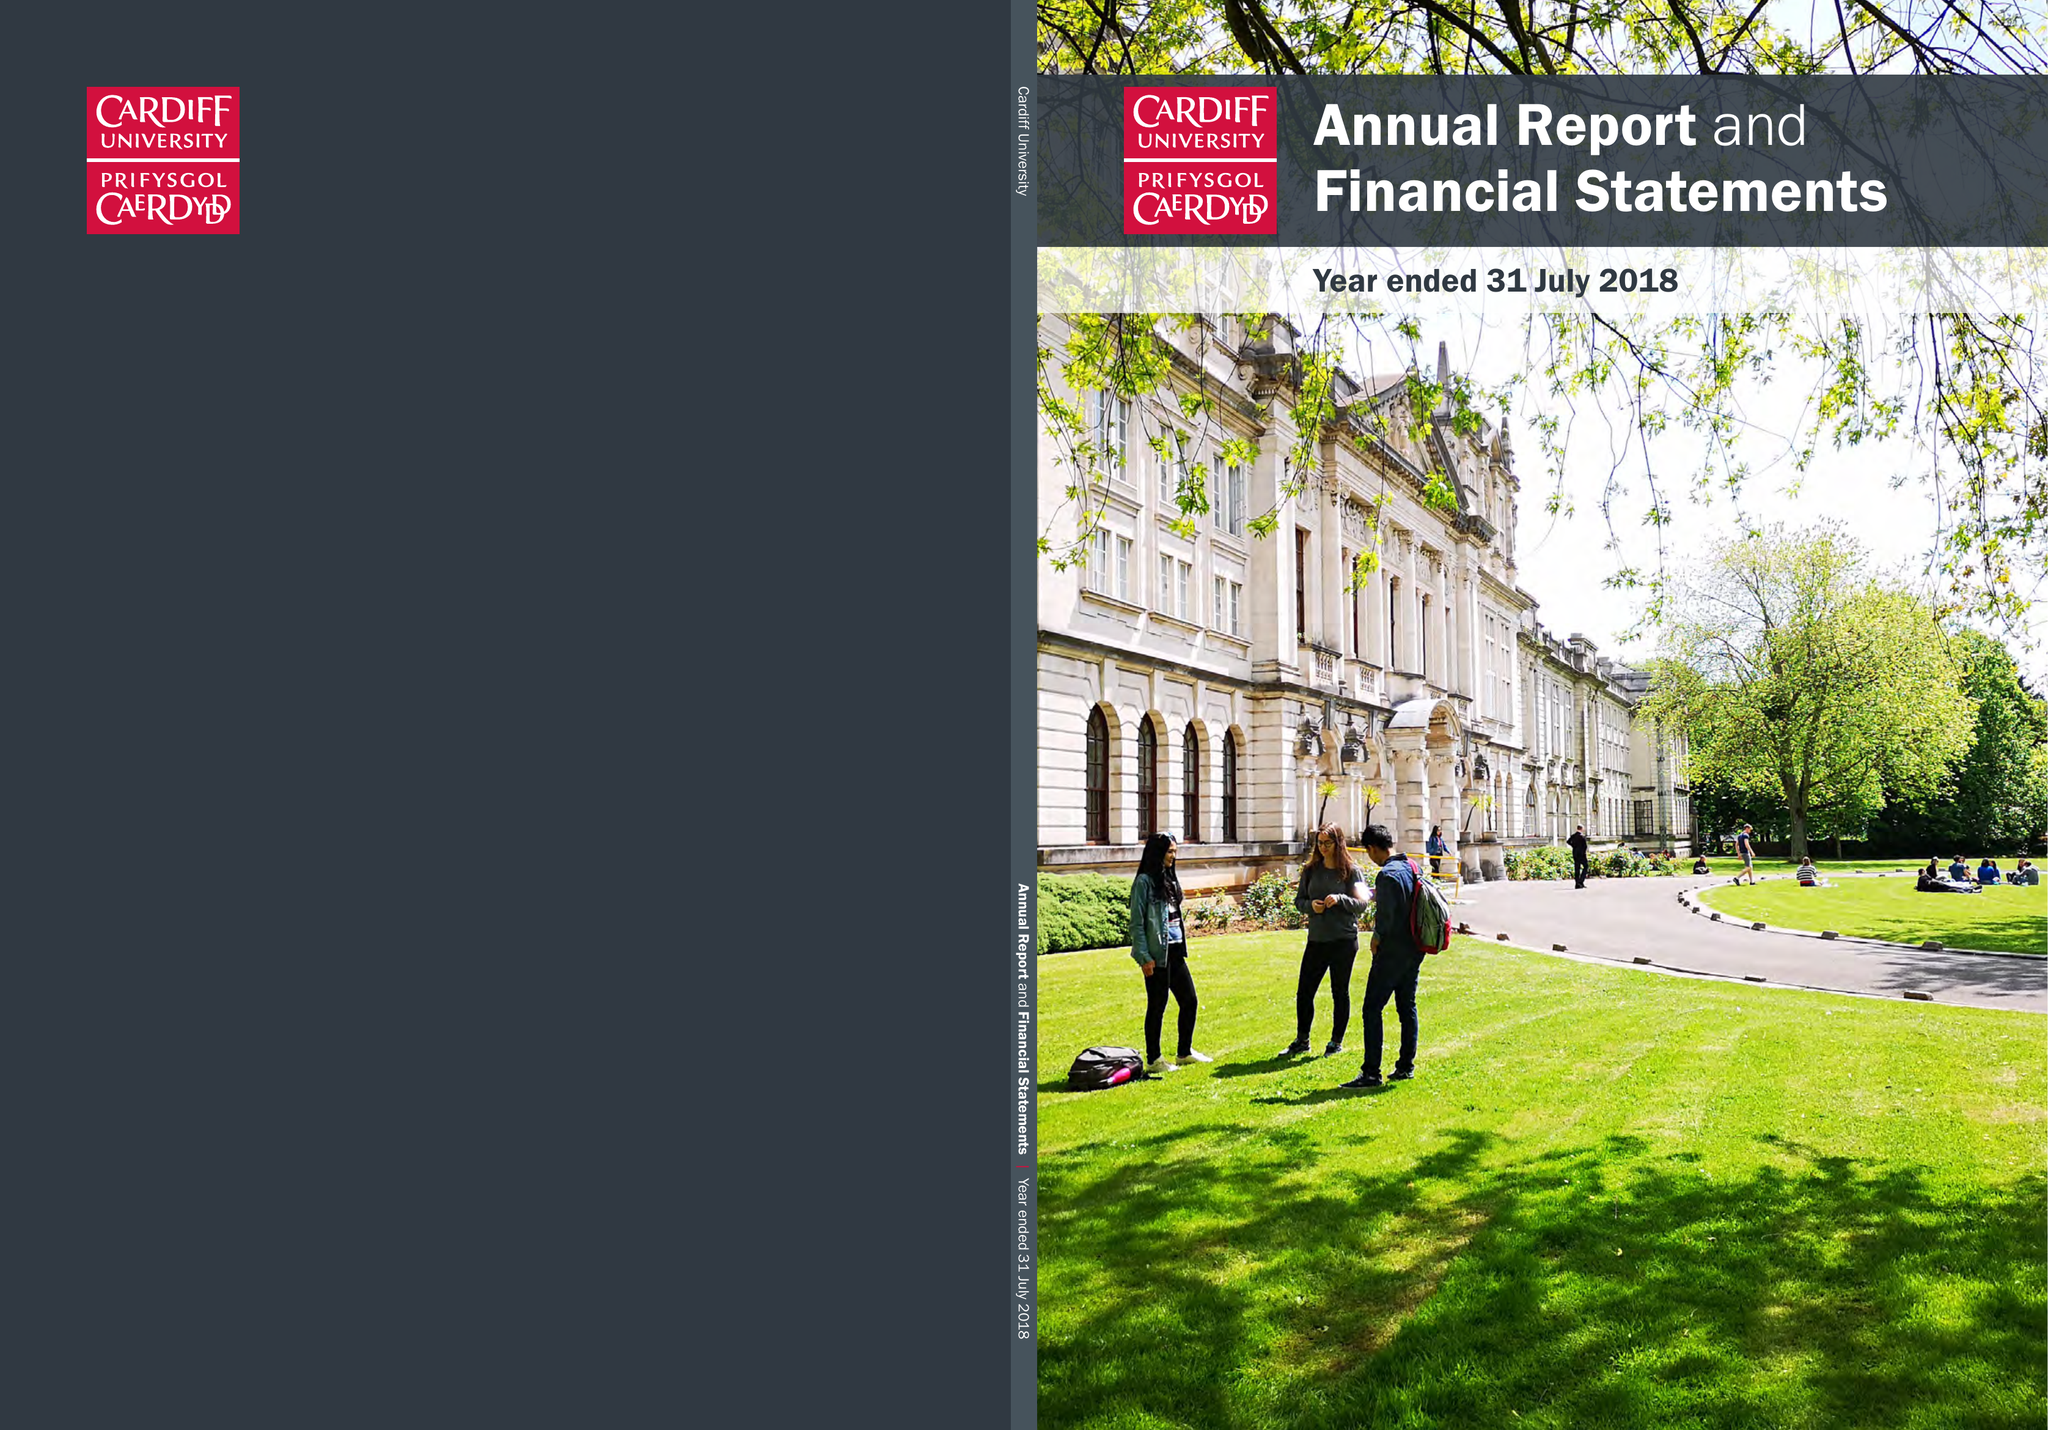What is the value for the charity_name?
Answer the question using a single word or phrase. Cardiff University 